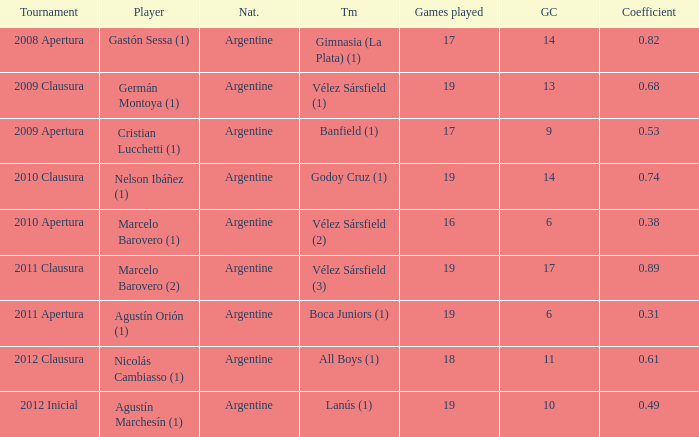What is the nationality of the 2012 clausura  tournament? Argentine. 